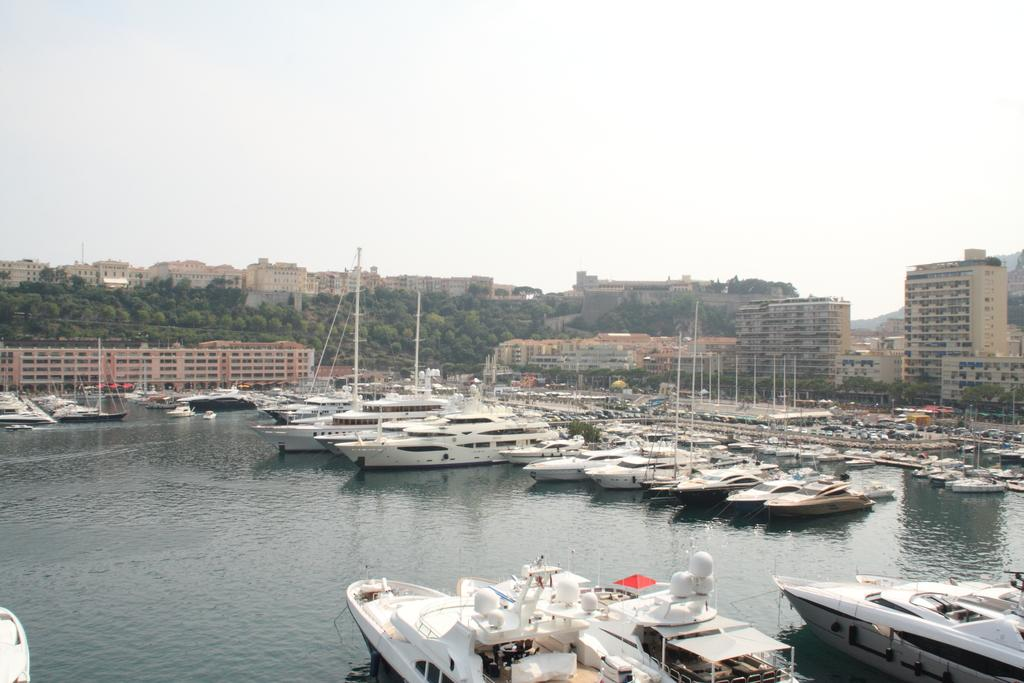What type of vehicles are in the image? There are boats in the image. Where are the boats located? The boats are on the water. What can be seen in the background of the image? There are buildings, trees, and the sky visible in the background of the image. What type of quilt is being used to cover the boats in the image? There is no quilt present in the image; the boats are on the water without any covering. 